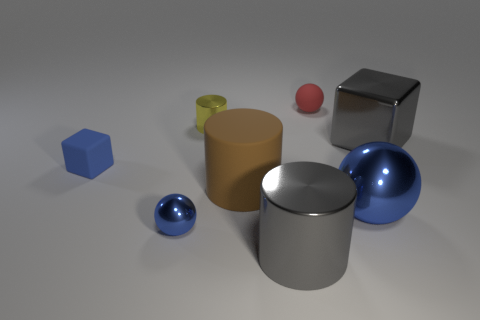What materials seem to be represented by the various objects in this image? The array of objects depicted in the image suggests the visualization of multiple materials. The blue and red spheres exhibit a glossy, reflective finish indicative of a polished metal or glass. The silver cube and cylinder share this reflective quality, hinting at a metallic composition. Contrastingly, the brown cylinder appears to have a matte finish, potentially signifying a ceramic or plastic material. Which object in the image seems to be the source of light? While no explicit light source is visible in the frame, the shadows cast by the objects and their reflections suggest an overhead lighting arrangement, likely positioned slightly to the right of the scene based on the angle and direction of the shadows and highlights. 